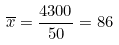<formula> <loc_0><loc_0><loc_500><loc_500>\overline { x } = \frac { 4 3 0 0 } { 5 0 } = 8 6</formula> 